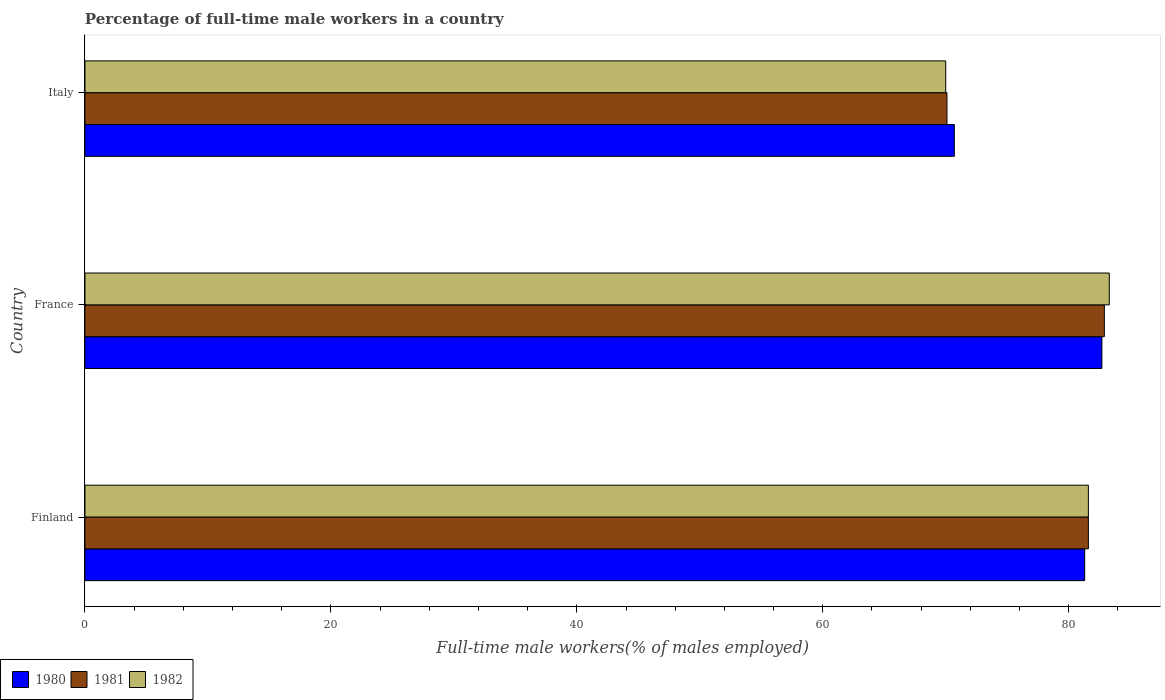How many different coloured bars are there?
Keep it short and to the point. 3. Are the number of bars per tick equal to the number of legend labels?
Your answer should be very brief. Yes. Are the number of bars on each tick of the Y-axis equal?
Offer a very short reply. Yes. How many bars are there on the 1st tick from the bottom?
Offer a very short reply. 3. What is the label of the 3rd group of bars from the top?
Ensure brevity in your answer.  Finland. What is the percentage of full-time male workers in 1980 in Finland?
Provide a succinct answer. 81.3. Across all countries, what is the maximum percentage of full-time male workers in 1980?
Offer a very short reply. 82.7. Across all countries, what is the minimum percentage of full-time male workers in 1982?
Offer a very short reply. 70. In which country was the percentage of full-time male workers in 1982 minimum?
Offer a very short reply. Italy. What is the total percentage of full-time male workers in 1980 in the graph?
Offer a terse response. 234.7. What is the difference between the percentage of full-time male workers in 1981 in Finland and that in France?
Offer a terse response. -1.3. What is the difference between the percentage of full-time male workers in 1981 in Finland and the percentage of full-time male workers in 1980 in France?
Provide a short and direct response. -1.1. What is the average percentage of full-time male workers in 1982 per country?
Provide a succinct answer. 78.3. What is the difference between the percentage of full-time male workers in 1982 and percentage of full-time male workers in 1981 in France?
Your answer should be compact. 0.4. In how many countries, is the percentage of full-time male workers in 1981 greater than 16 %?
Keep it short and to the point. 3. What is the ratio of the percentage of full-time male workers in 1981 in Finland to that in Italy?
Keep it short and to the point. 1.16. Is the percentage of full-time male workers in 1982 in France less than that in Italy?
Keep it short and to the point. No. Is the difference between the percentage of full-time male workers in 1982 in Finland and France greater than the difference between the percentage of full-time male workers in 1981 in Finland and France?
Keep it short and to the point. No. What is the difference between the highest and the second highest percentage of full-time male workers in 1982?
Ensure brevity in your answer.  1.7. What is the difference between the highest and the lowest percentage of full-time male workers in 1982?
Provide a short and direct response. 13.3. In how many countries, is the percentage of full-time male workers in 1982 greater than the average percentage of full-time male workers in 1982 taken over all countries?
Your answer should be compact. 2. Is the sum of the percentage of full-time male workers in 1982 in Finland and France greater than the maximum percentage of full-time male workers in 1980 across all countries?
Provide a succinct answer. Yes. What does the 2nd bar from the top in Finland represents?
Offer a very short reply. 1981. What does the 3rd bar from the bottom in Finland represents?
Your answer should be very brief. 1982. How many bars are there?
Give a very brief answer. 9. Are all the bars in the graph horizontal?
Offer a terse response. Yes. Does the graph contain grids?
Your answer should be compact. No. Where does the legend appear in the graph?
Provide a short and direct response. Bottom left. How many legend labels are there?
Provide a succinct answer. 3. What is the title of the graph?
Your answer should be compact. Percentage of full-time male workers in a country. Does "2007" appear as one of the legend labels in the graph?
Your response must be concise. No. What is the label or title of the X-axis?
Provide a succinct answer. Full-time male workers(% of males employed). What is the label or title of the Y-axis?
Your response must be concise. Country. What is the Full-time male workers(% of males employed) of 1980 in Finland?
Ensure brevity in your answer.  81.3. What is the Full-time male workers(% of males employed) in 1981 in Finland?
Give a very brief answer. 81.6. What is the Full-time male workers(% of males employed) in 1982 in Finland?
Keep it short and to the point. 81.6. What is the Full-time male workers(% of males employed) of 1980 in France?
Give a very brief answer. 82.7. What is the Full-time male workers(% of males employed) in 1981 in France?
Provide a short and direct response. 82.9. What is the Full-time male workers(% of males employed) of 1982 in France?
Offer a terse response. 83.3. What is the Full-time male workers(% of males employed) of 1980 in Italy?
Make the answer very short. 70.7. What is the Full-time male workers(% of males employed) of 1981 in Italy?
Your answer should be compact. 70.1. What is the Full-time male workers(% of males employed) in 1982 in Italy?
Ensure brevity in your answer.  70. Across all countries, what is the maximum Full-time male workers(% of males employed) of 1980?
Your answer should be compact. 82.7. Across all countries, what is the maximum Full-time male workers(% of males employed) in 1981?
Offer a very short reply. 82.9. Across all countries, what is the maximum Full-time male workers(% of males employed) of 1982?
Ensure brevity in your answer.  83.3. Across all countries, what is the minimum Full-time male workers(% of males employed) of 1980?
Ensure brevity in your answer.  70.7. Across all countries, what is the minimum Full-time male workers(% of males employed) of 1981?
Make the answer very short. 70.1. Across all countries, what is the minimum Full-time male workers(% of males employed) of 1982?
Make the answer very short. 70. What is the total Full-time male workers(% of males employed) in 1980 in the graph?
Your response must be concise. 234.7. What is the total Full-time male workers(% of males employed) in 1981 in the graph?
Provide a short and direct response. 234.6. What is the total Full-time male workers(% of males employed) in 1982 in the graph?
Your response must be concise. 234.9. What is the difference between the Full-time male workers(% of males employed) of 1980 in Finland and that in France?
Your answer should be very brief. -1.4. What is the difference between the Full-time male workers(% of males employed) of 1980 in Finland and that in Italy?
Offer a terse response. 10.6. What is the difference between the Full-time male workers(% of males employed) in 1981 in Finland and that in Italy?
Make the answer very short. 11.5. What is the difference between the Full-time male workers(% of males employed) in 1981 in Finland and the Full-time male workers(% of males employed) in 1982 in France?
Make the answer very short. -1.7. What is the difference between the Full-time male workers(% of males employed) in 1980 in Finland and the Full-time male workers(% of males employed) in 1982 in Italy?
Provide a short and direct response. 11.3. What is the difference between the Full-time male workers(% of males employed) in 1980 in France and the Full-time male workers(% of males employed) in 1981 in Italy?
Ensure brevity in your answer.  12.6. What is the difference between the Full-time male workers(% of males employed) of 1980 in France and the Full-time male workers(% of males employed) of 1982 in Italy?
Make the answer very short. 12.7. What is the average Full-time male workers(% of males employed) in 1980 per country?
Give a very brief answer. 78.23. What is the average Full-time male workers(% of males employed) of 1981 per country?
Make the answer very short. 78.2. What is the average Full-time male workers(% of males employed) of 1982 per country?
Keep it short and to the point. 78.3. What is the difference between the Full-time male workers(% of males employed) in 1980 and Full-time male workers(% of males employed) in 1981 in Finland?
Your answer should be compact. -0.3. What is the difference between the Full-time male workers(% of males employed) of 1980 and Full-time male workers(% of males employed) of 1982 in Finland?
Your answer should be very brief. -0.3. What is the difference between the Full-time male workers(% of males employed) in 1980 and Full-time male workers(% of males employed) in 1981 in France?
Keep it short and to the point. -0.2. What is the difference between the Full-time male workers(% of males employed) of 1980 and Full-time male workers(% of males employed) of 1982 in France?
Ensure brevity in your answer.  -0.6. What is the difference between the Full-time male workers(% of males employed) in 1980 and Full-time male workers(% of males employed) in 1982 in Italy?
Ensure brevity in your answer.  0.7. What is the ratio of the Full-time male workers(% of males employed) of 1980 in Finland to that in France?
Your response must be concise. 0.98. What is the ratio of the Full-time male workers(% of males employed) in 1981 in Finland to that in France?
Your response must be concise. 0.98. What is the ratio of the Full-time male workers(% of males employed) in 1982 in Finland to that in France?
Offer a very short reply. 0.98. What is the ratio of the Full-time male workers(% of males employed) of 1980 in Finland to that in Italy?
Keep it short and to the point. 1.15. What is the ratio of the Full-time male workers(% of males employed) in 1981 in Finland to that in Italy?
Ensure brevity in your answer.  1.16. What is the ratio of the Full-time male workers(% of males employed) in 1982 in Finland to that in Italy?
Offer a very short reply. 1.17. What is the ratio of the Full-time male workers(% of males employed) in 1980 in France to that in Italy?
Your answer should be very brief. 1.17. What is the ratio of the Full-time male workers(% of males employed) in 1981 in France to that in Italy?
Ensure brevity in your answer.  1.18. What is the ratio of the Full-time male workers(% of males employed) in 1982 in France to that in Italy?
Your response must be concise. 1.19. What is the difference between the highest and the second highest Full-time male workers(% of males employed) in 1981?
Ensure brevity in your answer.  1.3. What is the difference between the highest and the second highest Full-time male workers(% of males employed) of 1982?
Make the answer very short. 1.7. What is the difference between the highest and the lowest Full-time male workers(% of males employed) in 1980?
Offer a terse response. 12. What is the difference between the highest and the lowest Full-time male workers(% of males employed) in 1981?
Ensure brevity in your answer.  12.8. 